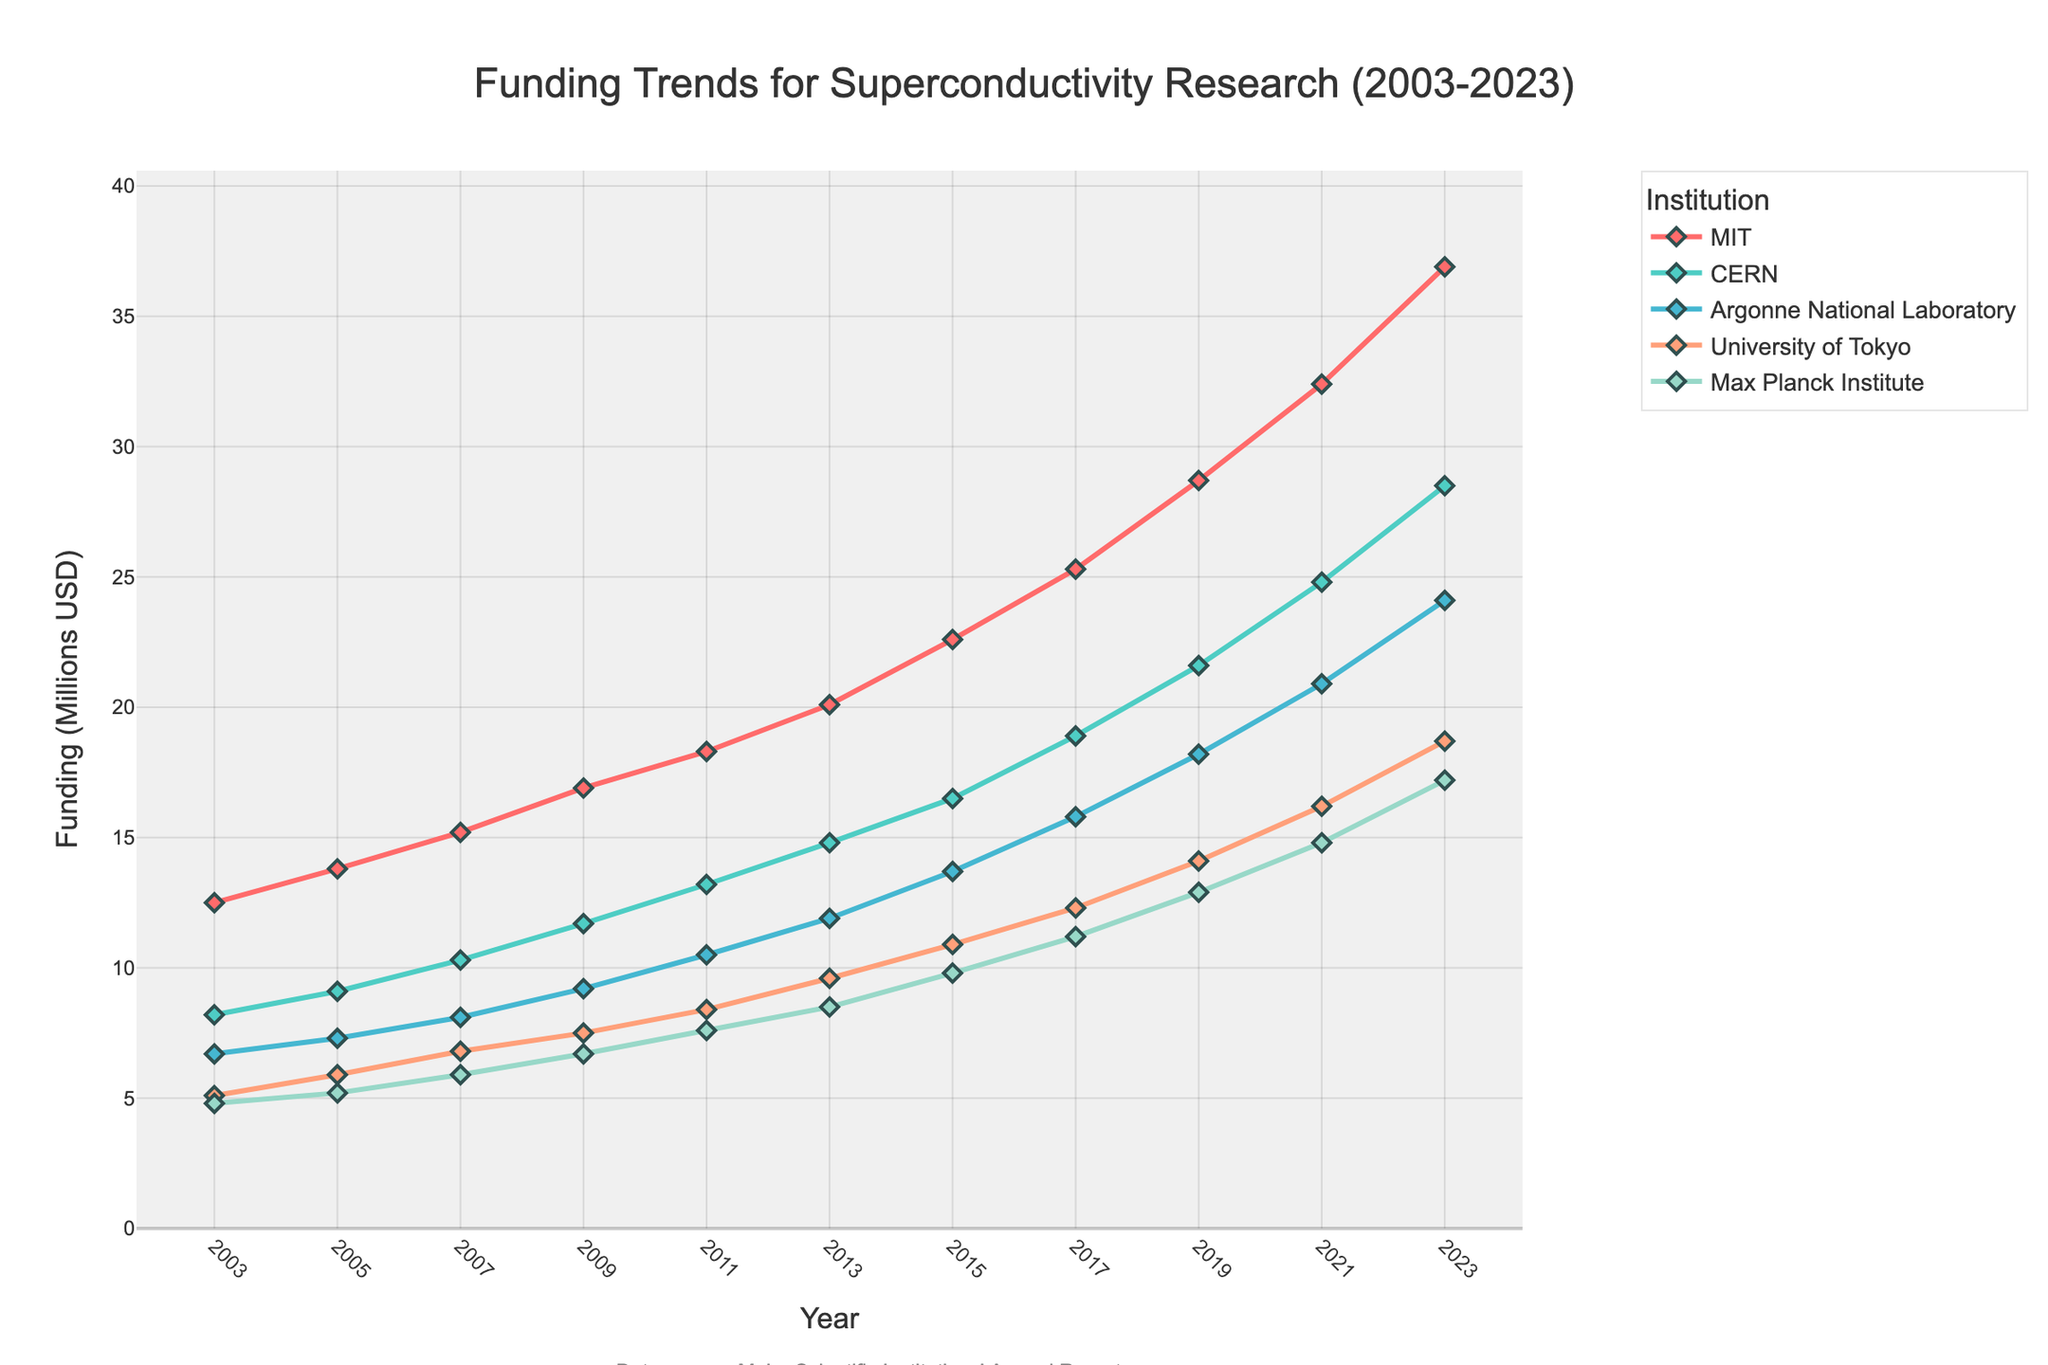Which institution had the highest funding in 2023? Observe the peaks at the end of the chart for each institution. MIT has the highest peak in 2023.
Answer: MIT What is the combined funding for MIT and CERN in 2023? Sum the funding for MIT and CERN in 2023: MIT (36.9) + CERN (28.5) = 65.4 million USD.
Answer: 65.4 million USD How did the funding for Argonne National Laboratory change from 2003 to 2023? Subtract the funding in 2003 from the funding in 2023 for Argonne National Laboratory: 24.1 - 6.7 = 17.4 million USD.
Answer: Increased by 17.4 million USD Which institution showed the least growth in funding over the 20 years? Calculate the difference between 2023 and 2003 for all institutions and compare: MIT (24.4), CERN (20.3), Argonne National Laboratory (17.4), University of Tokyo (13.6), Max Planck Institute (12.4). The Max Planck Institute showed the least growth.
Answer: Max Planck Institute How does the funding of the Max Planck Institute in 2021 compare to the funding of University of Tokyo in 2011? Retrieve the values from the chart: Max Planck Institute in 2021 (14.8) and University of Tokyo in 2011 (8.4). Compare them.
Answer: Max Planck Institute had higher funding What is the average funding for University of Tokyo over the first 5 data points? Calculate the sum of the first 5 data points for University of Tokyo and divide by 5: (5.1 + 5.9 + 6.8 + 7.5 + 8.4) / 5 = 6.74 million USD.
Answer: 6.74 million USD Which year saw the greatest increase in funding for CERN? Calculate the year-over-year change for CERN and identify the maximum increase: Largest increase is between 2019 (21.6) and 2021 (24.8) = 3.2 million USD.
Answer: 2021 Compare the funding trend for MIT and University of Tokyo between 2003 and 2023. Both institutions show an upward trend, with MIT increasing more sharply compared to University of Tokyo. MIT's funding increased from 12.5 to 36.9, while University of Tokyo's funding grew from 5.1 to 18.7.
Answer: MIT increased more sharply What is the difference in funding between MIT and Max Planck Institute in 2017? Subtract the funding of Max Planck Institute from MIT in 2017: MIT (25.3) - Max Planck Institute (11.2) = 14.1 million USD.
Answer: 14.1 million USD How does the overall trend of funding for superconductivity research appear over the 20 years for all institutions collectively? The funding trends for all institutions show a general upward trajectory, indicating increasing investment in superconductivity research over the 20 years.
Answer: Upward trajectory 